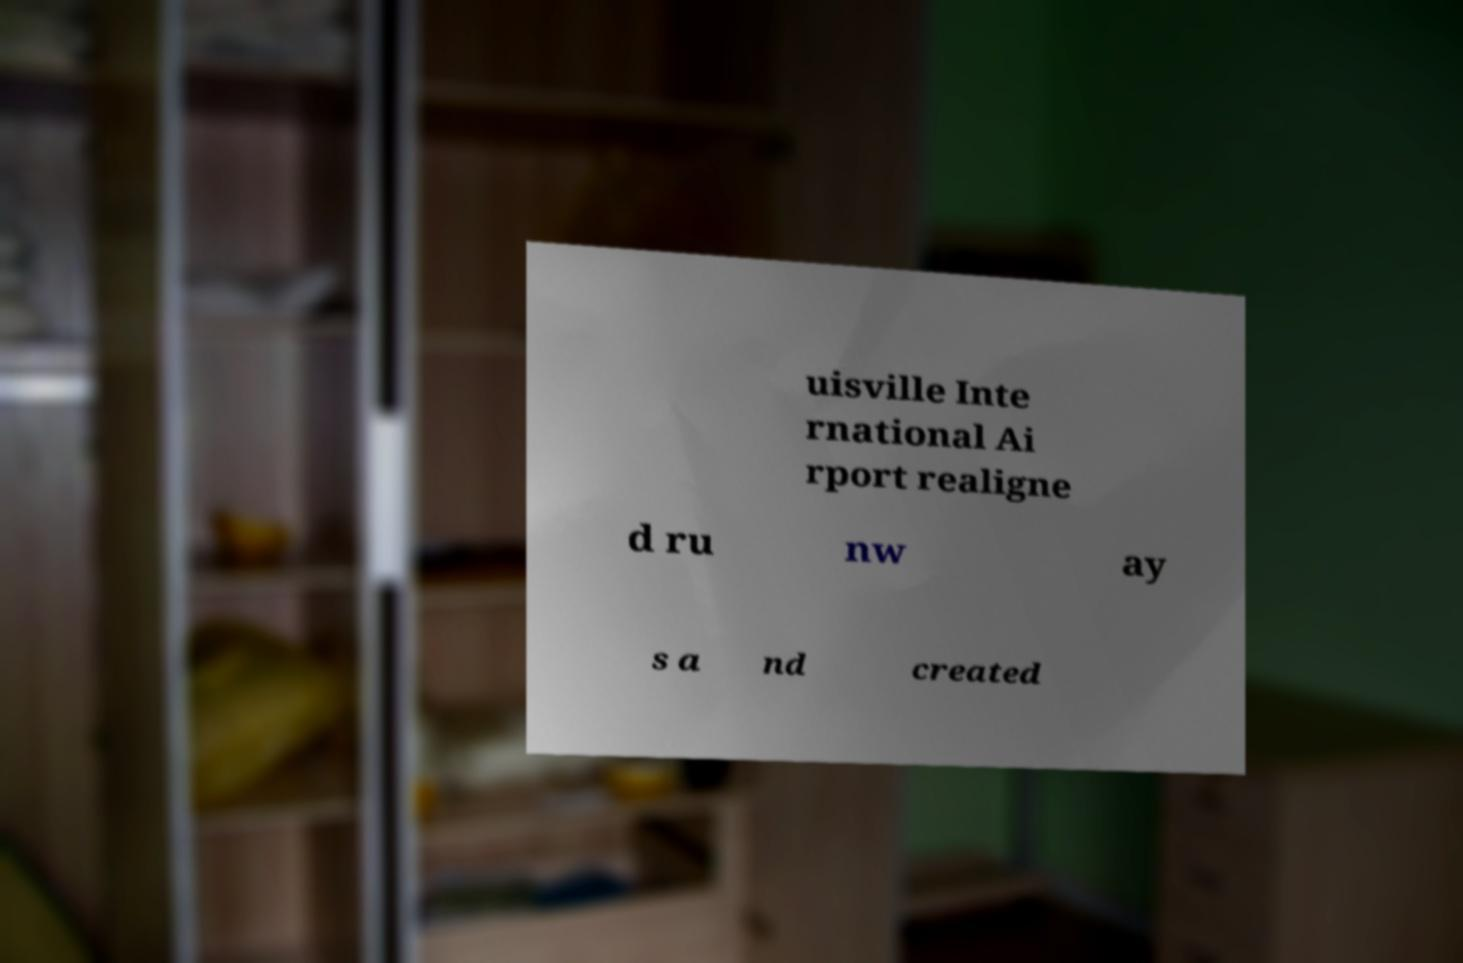For documentation purposes, I need the text within this image transcribed. Could you provide that? uisville Inte rnational Ai rport realigne d ru nw ay s a nd created 